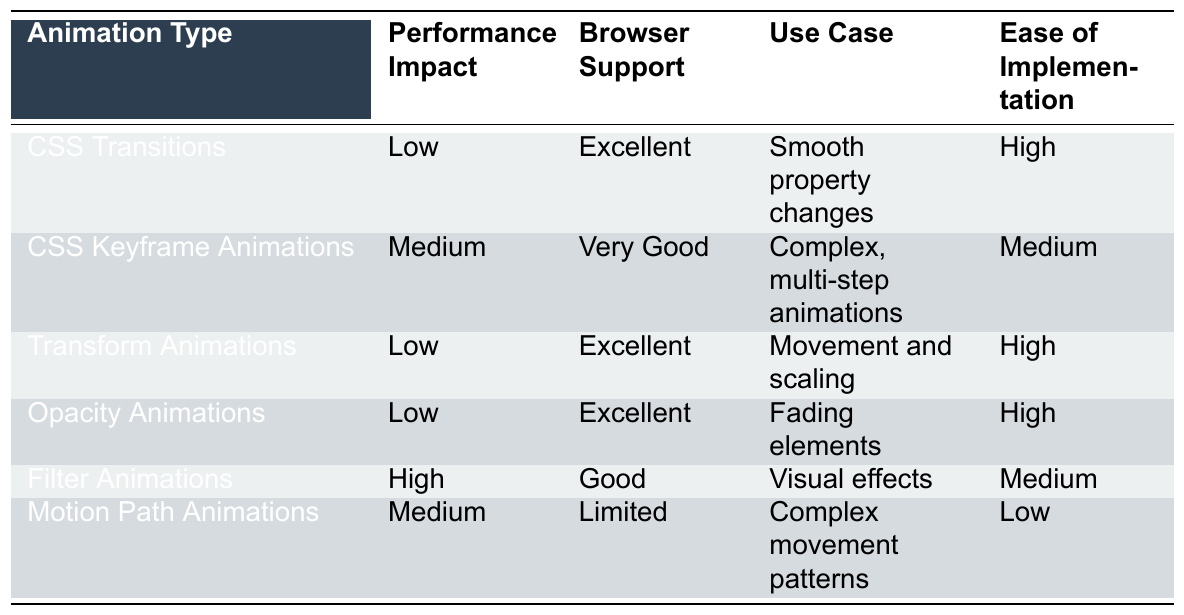What type of CSS animation has the highest performance impact? Filter Animations have the highest performance impact listed as "High" in the table.
Answer: Filter Animations Which animation types have excellent browser support? The animation types listed with excellent browser support are CSS Transitions, Transform Animations, and Opacity Animations.
Answer: 3 types Is the ease of implementation for CSS Keyframe Animations high? No, the table states that CSS Keyframe Animations have a medium ease of implementation.
Answer: No What is the use case for Motion Path Animations? Motion Path Animations are used for complex movement patterns, as indicated in the table.
Answer: Complex movement patterns How many animation types have a low performance impact? There are four animation types that have a low-performance impact: CSS Transitions, Transform Animations, Opacity Animations, and Filter Animations.
Answer: 4 types Among the animation types, which one is the easiest to implement? The easiest to implement animation types are CSS Transitions, Transform Animations, and Opacity Animations, all categorized as high ease of implementation.
Answer: 3 types Do all animation types have at least good browser support? Yes, all animation types have either excellent or good browser support according to the table.
Answer: Yes How does the performance impact of Filter Animations compare to that of Motion Path Animations? Filter Animations have a high performance impact, while Motion Path Animations have a medium performance impact, indicating that Filter Animations are more demanding.
Answer: Higher What is the average ease of implementation for the animation types listed? Four animation types have high ease (CSS Transitions, Transform Animations, Opacity Animations), and two have medium ease (CSS Keyframe Animations and Filter Animations). Thus, the average can be interpreted as closer to high given the majority are high.
Answer: Closer to high Which animation type has a medium performance impact and limited browser support? Motion Path Animations have both medium performance impact and limited browser support as specified in the table.
Answer: Motion Path Animations 